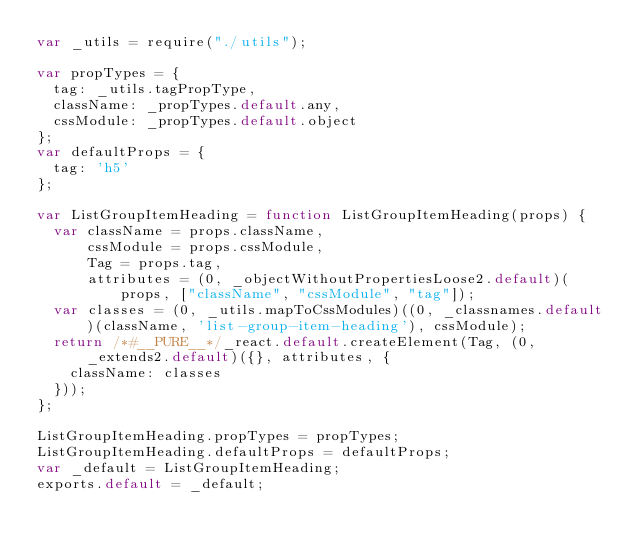<code> <loc_0><loc_0><loc_500><loc_500><_JavaScript_>var _utils = require("./utils");

var propTypes = {
  tag: _utils.tagPropType,
  className: _propTypes.default.any,
  cssModule: _propTypes.default.object
};
var defaultProps = {
  tag: 'h5'
};

var ListGroupItemHeading = function ListGroupItemHeading(props) {
  var className = props.className,
      cssModule = props.cssModule,
      Tag = props.tag,
      attributes = (0, _objectWithoutPropertiesLoose2.default)(props, ["className", "cssModule", "tag"]);
  var classes = (0, _utils.mapToCssModules)((0, _classnames.default)(className, 'list-group-item-heading'), cssModule);
  return /*#__PURE__*/_react.default.createElement(Tag, (0, _extends2.default)({}, attributes, {
    className: classes
  }));
};

ListGroupItemHeading.propTypes = propTypes;
ListGroupItemHeading.defaultProps = defaultProps;
var _default = ListGroupItemHeading;
exports.default = _default;</code> 